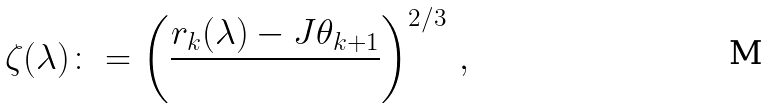<formula> <loc_0><loc_0><loc_500><loc_500>\zeta ( \lambda ) \colon = \left ( \frac { r _ { k } ( \lambda ) - J \theta _ { k + 1 } } { } \right ) ^ { 2 / 3 } \, ,</formula> 